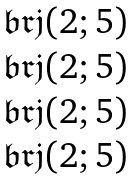<formula> <loc_0><loc_0><loc_500><loc_500>\begin{matrix} \mathfrak { b r j } ( 2 ; 5 ) \\ \mathfrak { b r j } ( 2 ; 5 ) \\ \mathfrak { b r j } ( 2 ; 5 ) \\ \mathfrak { b r j } ( 2 ; 5 ) \end{matrix}</formula> 